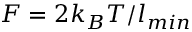<formula> <loc_0><loc_0><loc_500><loc_500>F = 2 k _ { B } T / l _ { \min }</formula> 